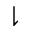<formula> <loc_0><loc_0><loc_500><loc_500>\downharpoonright</formula> 